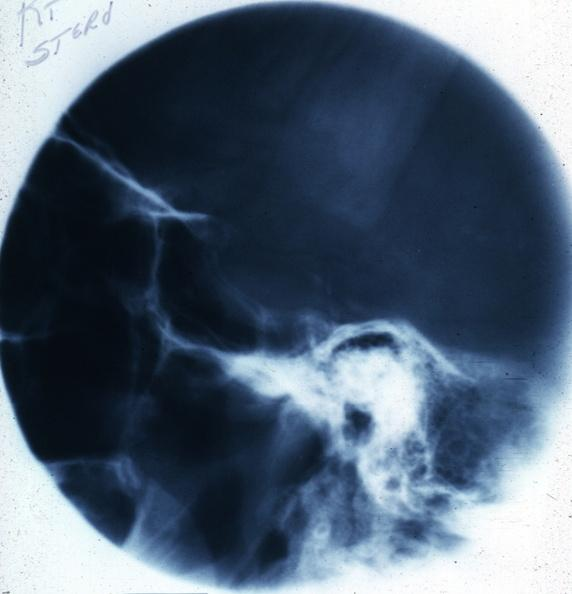s chromophobe adenoma present?
Answer the question using a single word or phrase. Yes 